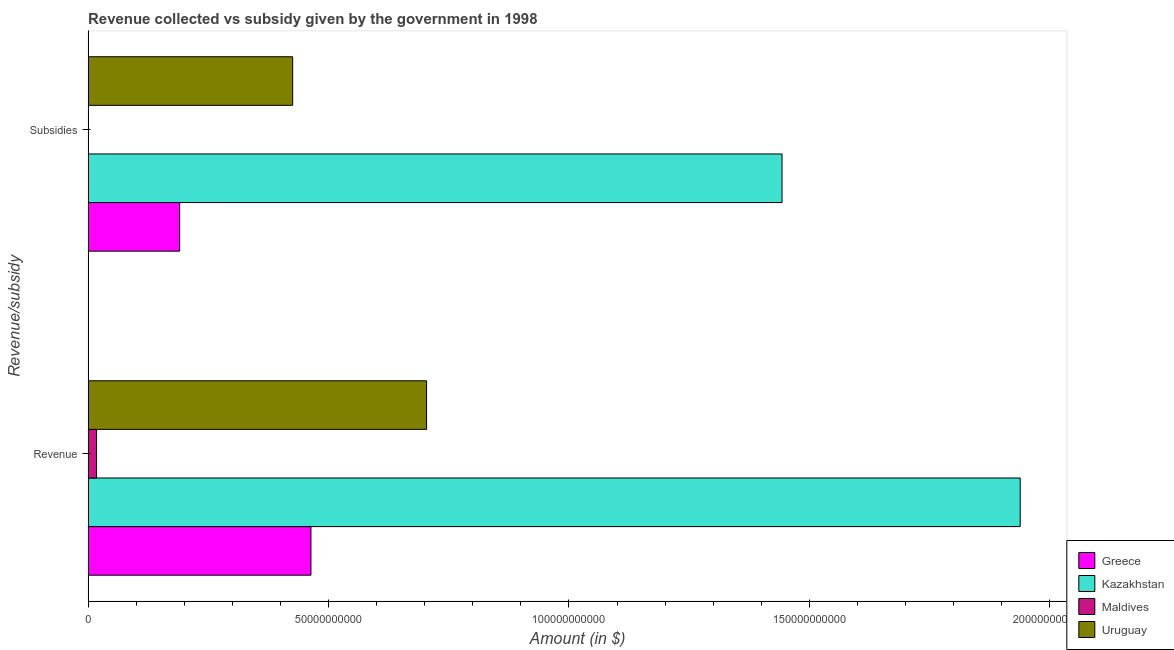How many different coloured bars are there?
Make the answer very short. 4. Are the number of bars per tick equal to the number of legend labels?
Give a very brief answer. Yes. How many bars are there on the 2nd tick from the top?
Ensure brevity in your answer.  4. How many bars are there on the 1st tick from the bottom?
Your response must be concise. 4. What is the label of the 2nd group of bars from the top?
Offer a terse response. Revenue. What is the amount of subsidies given in Uruguay?
Your answer should be very brief. 4.25e+1. Across all countries, what is the maximum amount of revenue collected?
Make the answer very short. 1.94e+11. Across all countries, what is the minimum amount of subsidies given?
Make the answer very short. 2.79e+07. In which country was the amount of revenue collected maximum?
Ensure brevity in your answer.  Kazakhstan. In which country was the amount of subsidies given minimum?
Keep it short and to the point. Maldives. What is the total amount of subsidies given in the graph?
Keep it short and to the point. 2.06e+11. What is the difference between the amount of revenue collected in Uruguay and that in Maldives?
Offer a very short reply. 6.86e+1. What is the difference between the amount of subsidies given in Uruguay and the amount of revenue collected in Greece?
Make the answer very short. -3.80e+09. What is the average amount of revenue collected per country?
Offer a very short reply. 7.81e+1. What is the difference between the amount of subsidies given and amount of revenue collected in Uruguay?
Offer a terse response. -2.78e+1. What is the ratio of the amount of revenue collected in Uruguay to that in Greece?
Your response must be concise. 1.52. Is the amount of subsidies given in Greece less than that in Uruguay?
Your answer should be compact. Yes. What does the 1st bar from the top in Revenue represents?
Your answer should be compact. Uruguay. What does the 2nd bar from the bottom in Subsidies represents?
Provide a succinct answer. Kazakhstan. How many bars are there?
Give a very brief answer. 8. Are all the bars in the graph horizontal?
Offer a very short reply. Yes. Are the values on the major ticks of X-axis written in scientific E-notation?
Provide a short and direct response. No. Does the graph contain grids?
Your answer should be compact. No. Where does the legend appear in the graph?
Provide a short and direct response. Bottom right. How many legend labels are there?
Your answer should be compact. 4. How are the legend labels stacked?
Make the answer very short. Vertical. What is the title of the graph?
Make the answer very short. Revenue collected vs subsidy given by the government in 1998. Does "Zimbabwe" appear as one of the legend labels in the graph?
Offer a terse response. No. What is the label or title of the X-axis?
Provide a short and direct response. Amount (in $). What is the label or title of the Y-axis?
Provide a succinct answer. Revenue/subsidy. What is the Amount (in $) of Greece in Revenue?
Your answer should be compact. 4.63e+1. What is the Amount (in $) of Kazakhstan in Revenue?
Provide a succinct answer. 1.94e+11. What is the Amount (in $) of Maldives in Revenue?
Your answer should be very brief. 1.76e+09. What is the Amount (in $) of Uruguay in Revenue?
Offer a very short reply. 7.04e+1. What is the Amount (in $) in Greece in Subsidies?
Your answer should be very brief. 1.90e+1. What is the Amount (in $) in Kazakhstan in Subsidies?
Provide a short and direct response. 1.44e+11. What is the Amount (in $) in Maldives in Subsidies?
Provide a succinct answer. 2.79e+07. What is the Amount (in $) in Uruguay in Subsidies?
Provide a short and direct response. 4.25e+1. Across all Revenue/subsidy, what is the maximum Amount (in $) of Greece?
Keep it short and to the point. 4.63e+1. Across all Revenue/subsidy, what is the maximum Amount (in $) in Kazakhstan?
Offer a terse response. 1.94e+11. Across all Revenue/subsidy, what is the maximum Amount (in $) in Maldives?
Offer a very short reply. 1.76e+09. Across all Revenue/subsidy, what is the maximum Amount (in $) of Uruguay?
Provide a succinct answer. 7.04e+1. Across all Revenue/subsidy, what is the minimum Amount (in $) in Greece?
Give a very brief answer. 1.90e+1. Across all Revenue/subsidy, what is the minimum Amount (in $) in Kazakhstan?
Offer a very short reply. 1.44e+11. Across all Revenue/subsidy, what is the minimum Amount (in $) in Maldives?
Your answer should be very brief. 2.79e+07. Across all Revenue/subsidy, what is the minimum Amount (in $) in Uruguay?
Offer a very short reply. 4.25e+1. What is the total Amount (in $) in Greece in the graph?
Give a very brief answer. 6.54e+1. What is the total Amount (in $) of Kazakhstan in the graph?
Ensure brevity in your answer.  3.38e+11. What is the total Amount (in $) of Maldives in the graph?
Ensure brevity in your answer.  1.79e+09. What is the total Amount (in $) of Uruguay in the graph?
Make the answer very short. 1.13e+11. What is the difference between the Amount (in $) of Greece in Revenue and that in Subsidies?
Ensure brevity in your answer.  2.73e+1. What is the difference between the Amount (in $) of Kazakhstan in Revenue and that in Subsidies?
Make the answer very short. 4.95e+1. What is the difference between the Amount (in $) of Maldives in Revenue and that in Subsidies?
Make the answer very short. 1.74e+09. What is the difference between the Amount (in $) in Uruguay in Revenue and that in Subsidies?
Ensure brevity in your answer.  2.78e+1. What is the difference between the Amount (in $) of Greece in Revenue and the Amount (in $) of Kazakhstan in Subsidies?
Provide a succinct answer. -9.80e+1. What is the difference between the Amount (in $) of Greece in Revenue and the Amount (in $) of Maldives in Subsidies?
Ensure brevity in your answer.  4.63e+1. What is the difference between the Amount (in $) in Greece in Revenue and the Amount (in $) in Uruguay in Subsidies?
Keep it short and to the point. 3.80e+09. What is the difference between the Amount (in $) of Kazakhstan in Revenue and the Amount (in $) of Maldives in Subsidies?
Provide a succinct answer. 1.94e+11. What is the difference between the Amount (in $) in Kazakhstan in Revenue and the Amount (in $) in Uruguay in Subsidies?
Offer a very short reply. 1.51e+11. What is the difference between the Amount (in $) of Maldives in Revenue and the Amount (in $) of Uruguay in Subsidies?
Give a very brief answer. -4.08e+1. What is the average Amount (in $) of Greece per Revenue/subsidy?
Provide a succinct answer. 3.27e+1. What is the average Amount (in $) of Kazakhstan per Revenue/subsidy?
Your answer should be compact. 1.69e+11. What is the average Amount (in $) of Maldives per Revenue/subsidy?
Provide a short and direct response. 8.96e+08. What is the average Amount (in $) of Uruguay per Revenue/subsidy?
Ensure brevity in your answer.  5.65e+1. What is the difference between the Amount (in $) in Greece and Amount (in $) in Kazakhstan in Revenue?
Your response must be concise. -1.47e+11. What is the difference between the Amount (in $) of Greece and Amount (in $) of Maldives in Revenue?
Offer a terse response. 4.46e+1. What is the difference between the Amount (in $) in Greece and Amount (in $) in Uruguay in Revenue?
Your answer should be compact. -2.40e+1. What is the difference between the Amount (in $) of Kazakhstan and Amount (in $) of Maldives in Revenue?
Make the answer very short. 1.92e+11. What is the difference between the Amount (in $) in Kazakhstan and Amount (in $) in Uruguay in Revenue?
Give a very brief answer. 1.23e+11. What is the difference between the Amount (in $) of Maldives and Amount (in $) of Uruguay in Revenue?
Keep it short and to the point. -6.86e+1. What is the difference between the Amount (in $) in Greece and Amount (in $) in Kazakhstan in Subsidies?
Your answer should be very brief. -1.25e+11. What is the difference between the Amount (in $) in Greece and Amount (in $) in Maldives in Subsidies?
Keep it short and to the point. 1.90e+1. What is the difference between the Amount (in $) of Greece and Amount (in $) of Uruguay in Subsidies?
Ensure brevity in your answer.  -2.35e+1. What is the difference between the Amount (in $) in Kazakhstan and Amount (in $) in Maldives in Subsidies?
Your answer should be compact. 1.44e+11. What is the difference between the Amount (in $) in Kazakhstan and Amount (in $) in Uruguay in Subsidies?
Make the answer very short. 1.02e+11. What is the difference between the Amount (in $) of Maldives and Amount (in $) of Uruguay in Subsidies?
Offer a very short reply. -4.25e+1. What is the ratio of the Amount (in $) in Greece in Revenue to that in Subsidies?
Make the answer very short. 2.43. What is the ratio of the Amount (in $) of Kazakhstan in Revenue to that in Subsidies?
Ensure brevity in your answer.  1.34. What is the ratio of the Amount (in $) of Maldives in Revenue to that in Subsidies?
Provide a short and direct response. 63.21. What is the ratio of the Amount (in $) of Uruguay in Revenue to that in Subsidies?
Offer a terse response. 1.65. What is the difference between the highest and the second highest Amount (in $) of Greece?
Your answer should be very brief. 2.73e+1. What is the difference between the highest and the second highest Amount (in $) in Kazakhstan?
Provide a short and direct response. 4.95e+1. What is the difference between the highest and the second highest Amount (in $) in Maldives?
Offer a very short reply. 1.74e+09. What is the difference between the highest and the second highest Amount (in $) in Uruguay?
Your answer should be very brief. 2.78e+1. What is the difference between the highest and the lowest Amount (in $) in Greece?
Your answer should be compact. 2.73e+1. What is the difference between the highest and the lowest Amount (in $) in Kazakhstan?
Provide a succinct answer. 4.95e+1. What is the difference between the highest and the lowest Amount (in $) of Maldives?
Make the answer very short. 1.74e+09. What is the difference between the highest and the lowest Amount (in $) in Uruguay?
Provide a succinct answer. 2.78e+1. 